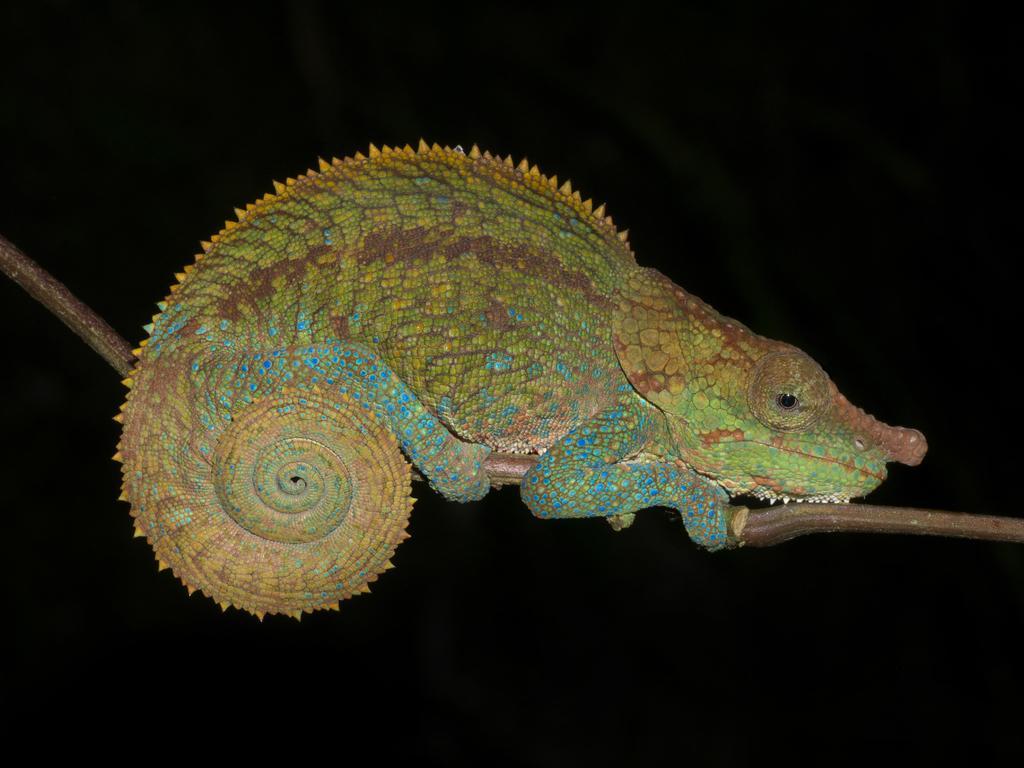Can you describe this image briefly? In this picture we can see a reptile and there is a dark background. 